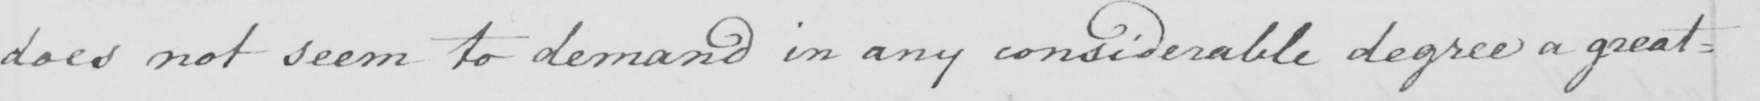Can you tell me what this handwritten text says? does not seem to demand in any considerable degree a great= 